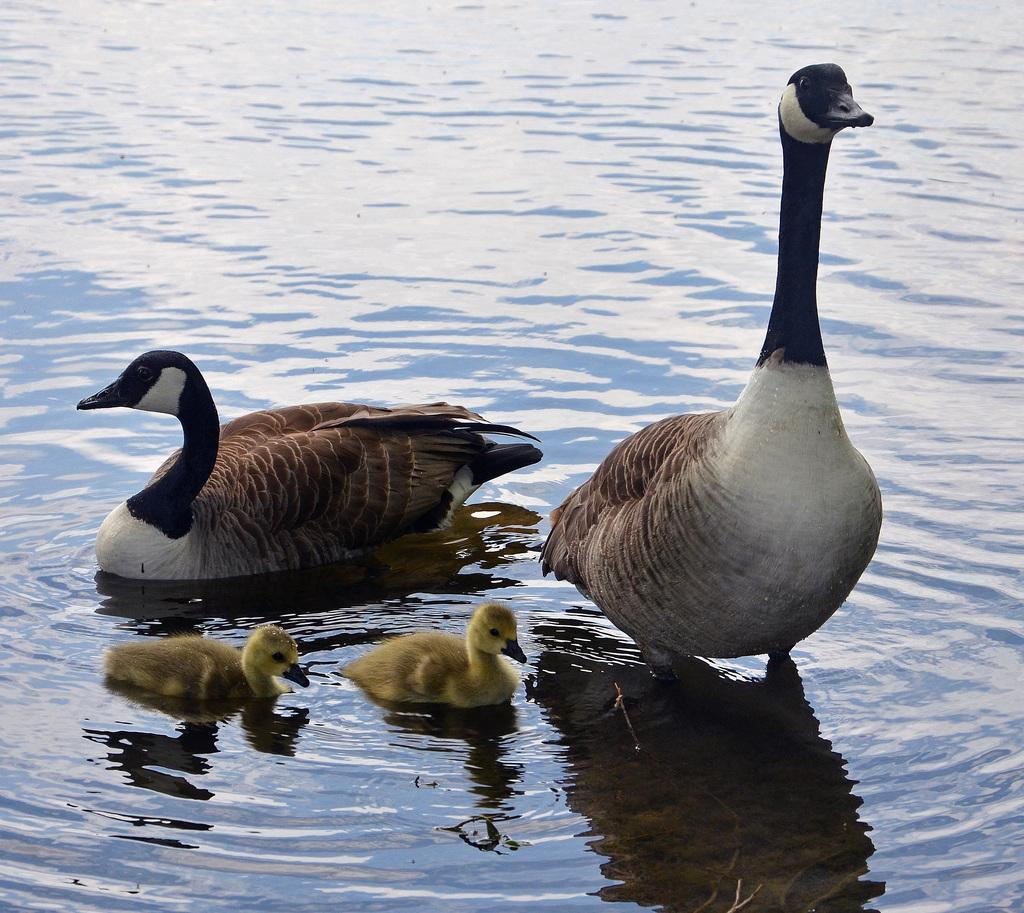What is present in the image? There is water and two ducks in the image. Can you describe the ducks in the water? One duck is brown, and the other is black. Are there any other animals in the water? Yes, there are two ducklings in the water. Where is the parcel being delivered in the image? There is no parcel present in the image. Can you describe the process of the ducks walking on the sidewalk in the image? There is no sidewalk or ducks walking in the image; it features water with ducks and ducklings. 